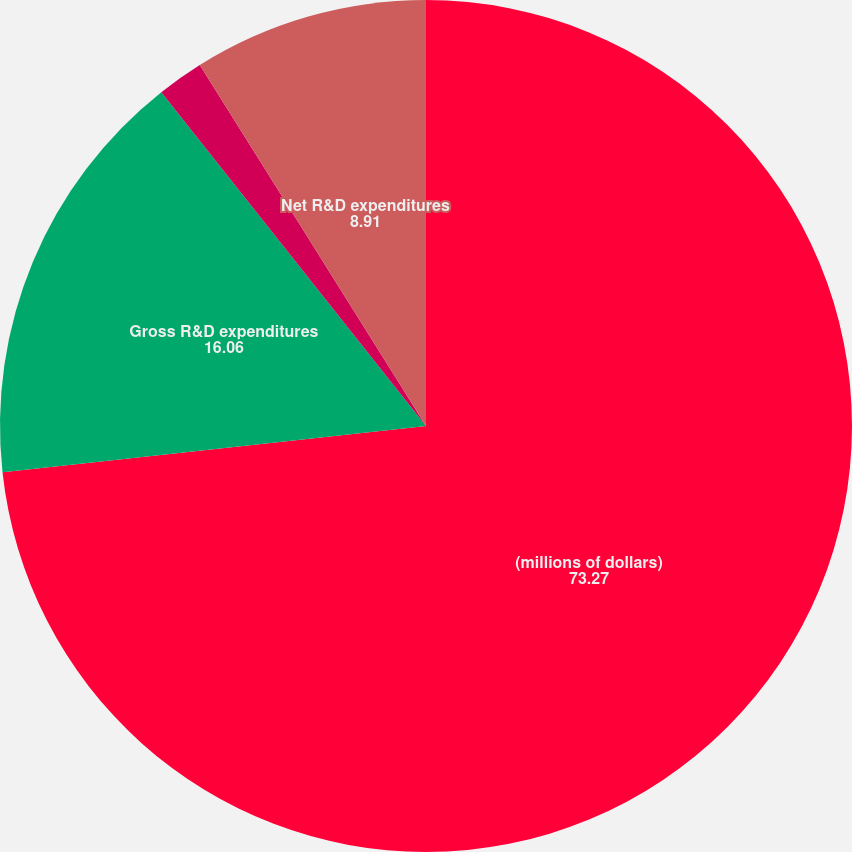Convert chart. <chart><loc_0><loc_0><loc_500><loc_500><pie_chart><fcel>(millions of dollars)<fcel>Gross R&D expenditures<fcel>Customer reimbursements<fcel>Net R&D expenditures<nl><fcel>73.27%<fcel>16.06%<fcel>1.76%<fcel>8.91%<nl></chart> 